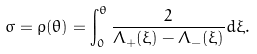Convert formula to latex. <formula><loc_0><loc_0><loc_500><loc_500>\sigma = \rho ( \theta ) = \int _ { 0 } ^ { \theta } \frac { 2 } { \Lambda _ { + } ( \xi ) - \Lambda _ { - } ( \xi ) } d \xi .</formula> 